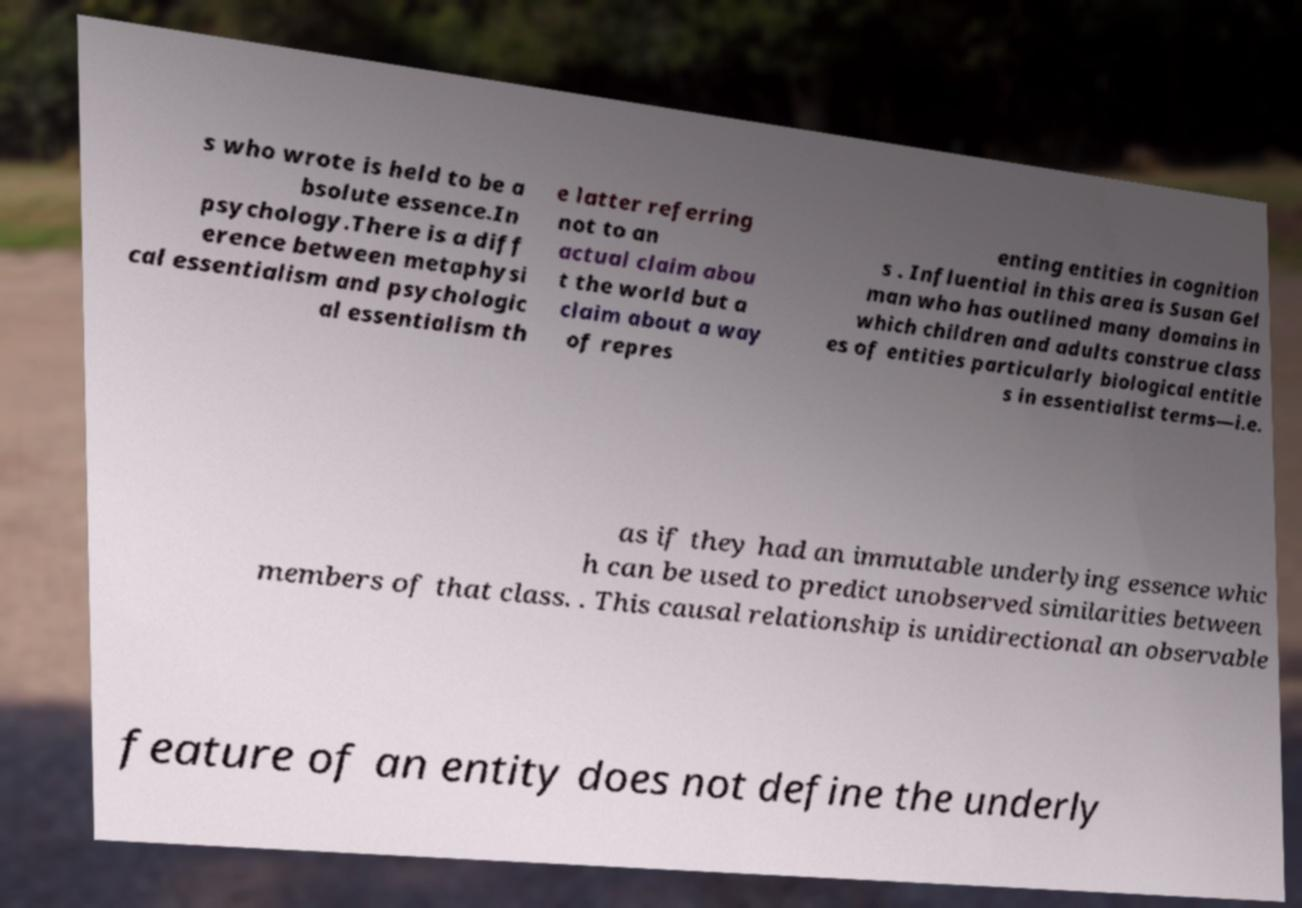Please read and relay the text visible in this image. What does it say? s who wrote is held to be a bsolute essence.In psychology.There is a diff erence between metaphysi cal essentialism and psychologic al essentialism th e latter referring not to an actual claim abou t the world but a claim about a way of repres enting entities in cognition s . Influential in this area is Susan Gel man who has outlined many domains in which children and adults construe class es of entities particularly biological entitie s in essentialist terms—i.e. as if they had an immutable underlying essence whic h can be used to predict unobserved similarities between members of that class. . This causal relationship is unidirectional an observable feature of an entity does not define the underly 